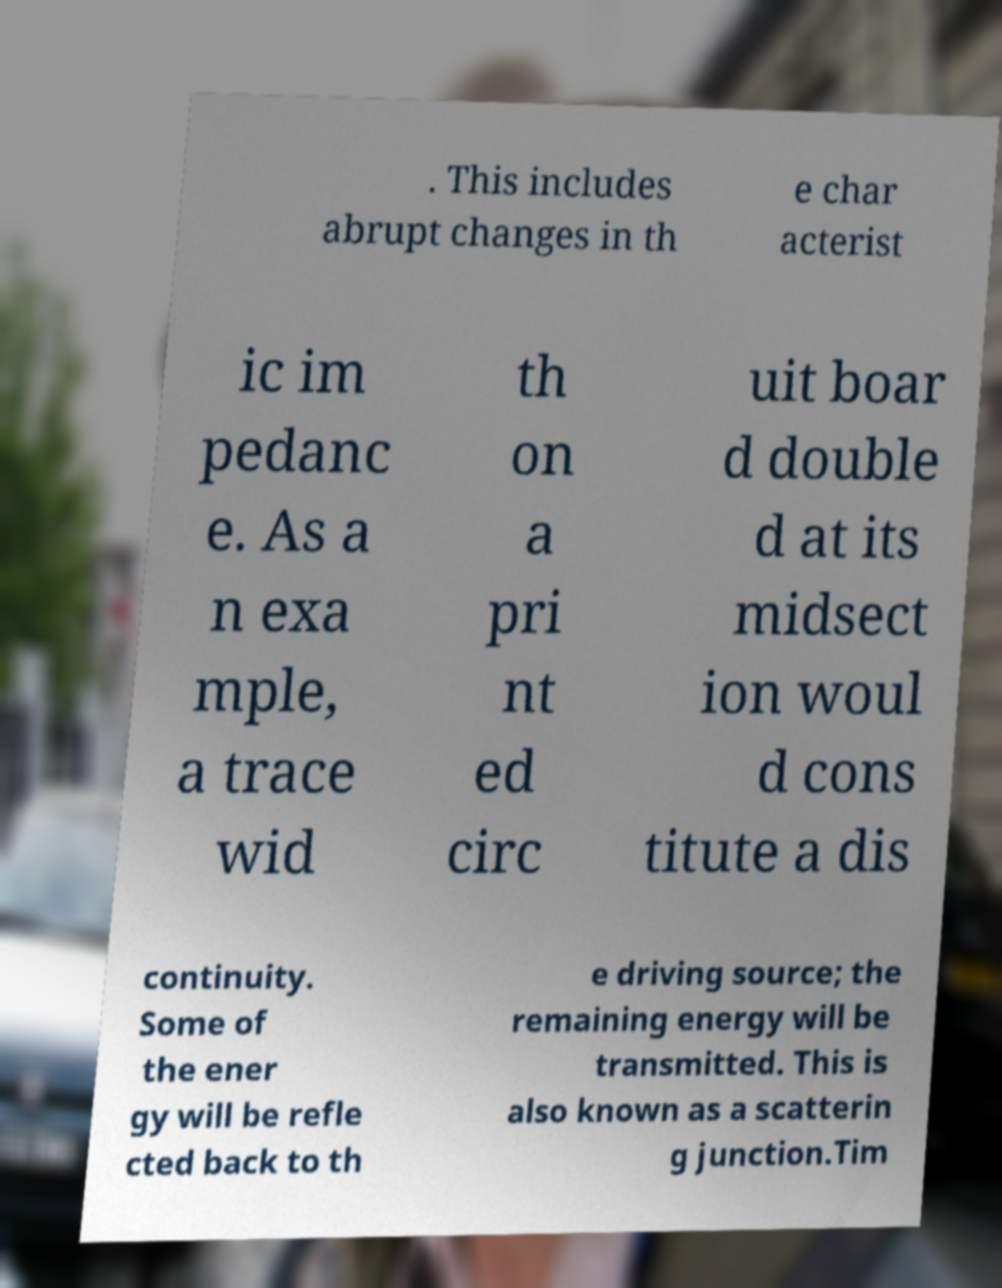What messages or text are displayed in this image? I need them in a readable, typed format. . This includes abrupt changes in th e char acterist ic im pedanc e. As a n exa mple, a trace wid th on a pri nt ed circ uit boar d double d at its midsect ion woul d cons titute a dis continuity. Some of the ener gy will be refle cted back to th e driving source; the remaining energy will be transmitted. This is also known as a scatterin g junction.Tim 